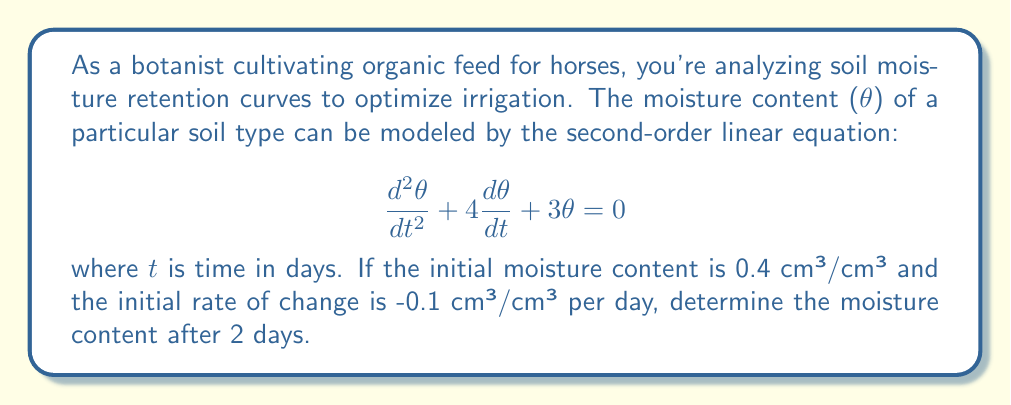Can you solve this math problem? To solve this problem, we need to follow these steps:

1) The general solution for this second-order linear equation is:
   $$\theta(t) = c_1e^{-t} + c_2e^{-3t}$$

2) We need to find $c_1$ and $c_2$ using the initial conditions:
   At $t=0$, $\theta(0) = 0.4$ and $\frac{d\theta}{dt}(0) = -0.1$

3) Using the first condition:
   $$\theta(0) = c_1 + c_2 = 0.4$$

4) For the second condition, we differentiate $\theta(t)$:
   $$\frac{d\theta}{dt} = -c_1e^{-t} - 3c_2e^{-3t}$$
   At $t=0$: $-c_1 - 3c_2 = -0.1$

5) Now we have a system of equations:
   $$c_1 + c_2 = 0.4$$
   $$c_1 + 3c_2 = 0.1$$

6) Subtracting the first equation from the second:
   $$2c_2 = -0.3$$
   $$c_2 = -0.15$$

7) Substituting back into the first equation:
   $$c_1 = 0.4 - (-0.15) = 0.55$$

8) Now we have our solution:
   $$\theta(t) = 0.55e^{-t} - 0.15e^{-3t}$$

9) To find $\theta(2)$, we substitute $t=2$:
   $$\theta(2) = 0.55e^{-2} - 0.15e^{-6}$$

10) Calculating this:
    $$\theta(2) = 0.55 * 0.1353 - 0.15 * 0.0025 = 0.074368$$
Answer: The moisture content after 2 days is approximately 0.0744 cm³/cm³. 